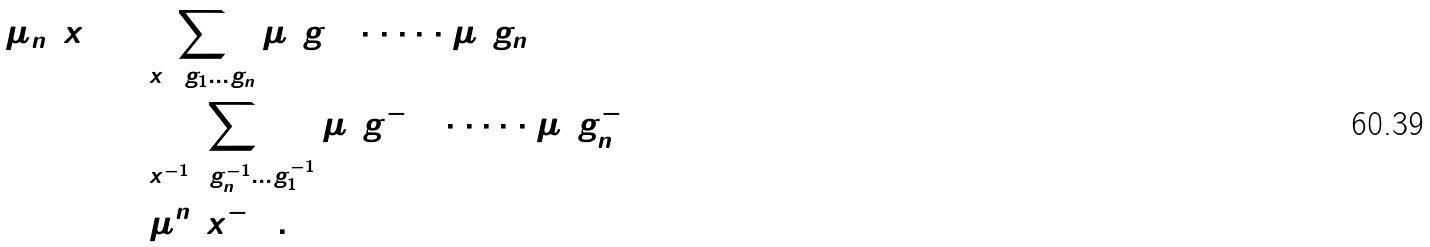<formula> <loc_0><loc_0><loc_500><loc_500>\mu _ { n } ( x ) & = \sum _ { x = g _ { 1 } \dots g _ { n } } \mu ( g _ { 1 } ) \cdot \dots \cdot \mu ( g _ { n } ) \\ & = \sum _ { x ^ { - 1 } = g ^ { - 1 } _ { n } \dots g ^ { - 1 } _ { 1 } } \check { \mu } ( g _ { 1 } ^ { - 1 } ) \cdot \dots \cdot \check { \mu } ( g _ { n } ^ { - 1 } ) \\ & = \check { \mu } ^ { n } ( x ^ { - 1 } ) .</formula> 